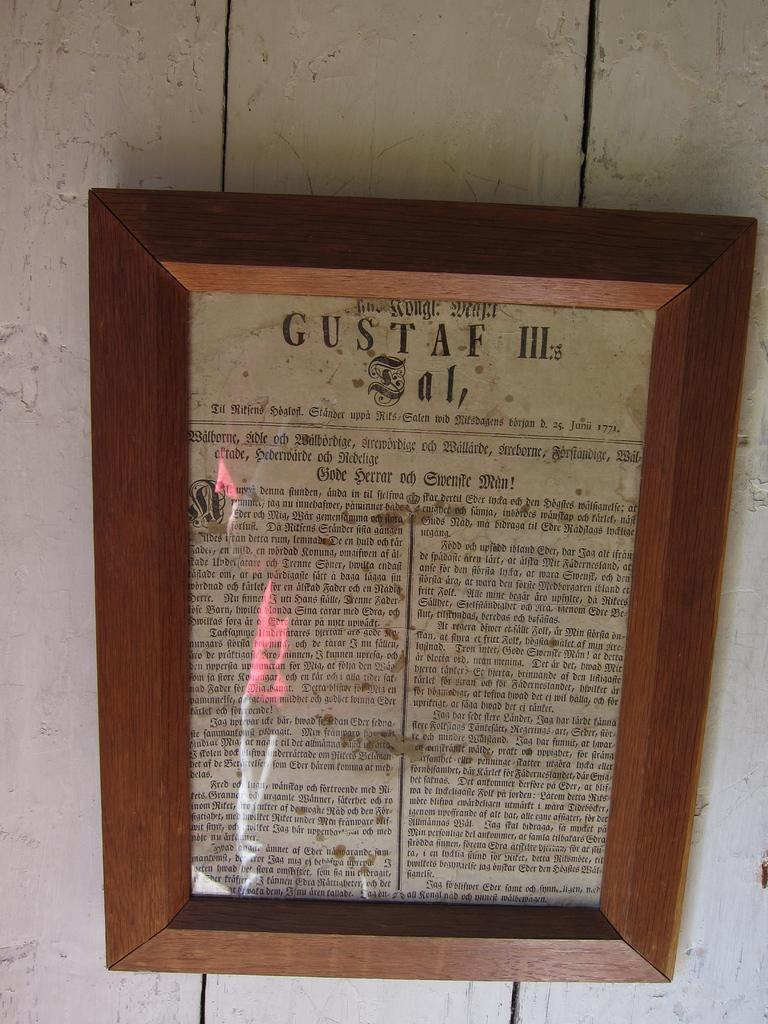<image>
Summarize the visual content of the image. a paper that is framed with a wooden frame, that is labeled 'gustaf III' on the top 